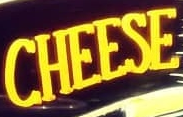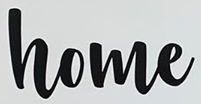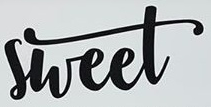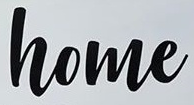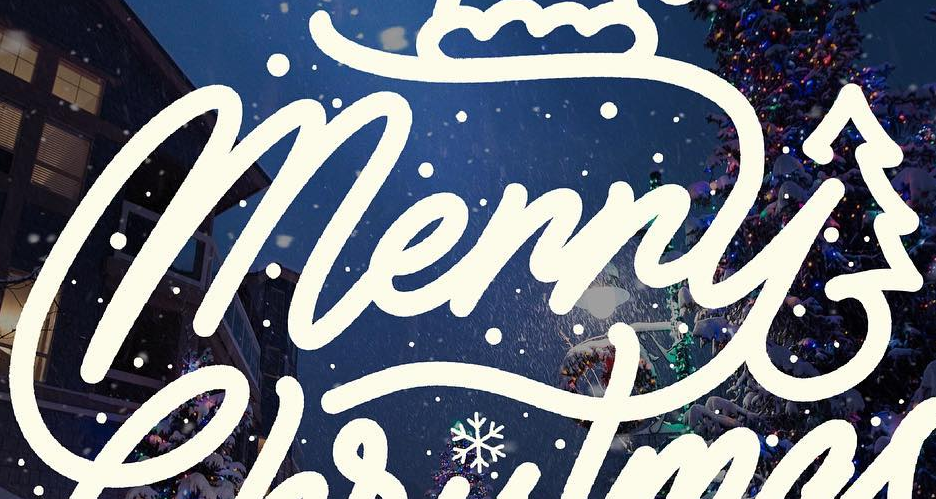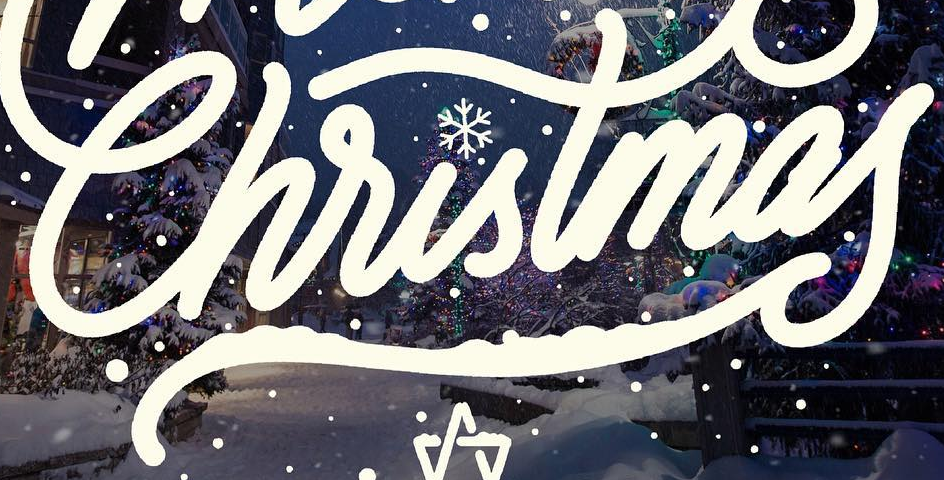What words can you see in these images in sequence, separated by a semicolon? CHEESE; home; sheet; home; Merry; Christmas 